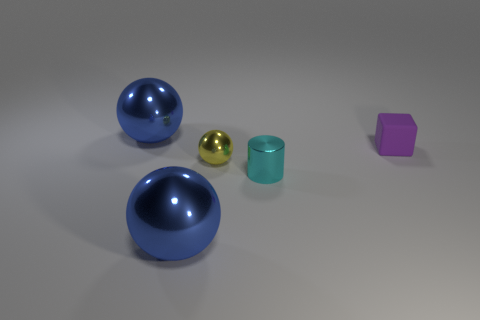What number of other objects are the same size as the rubber object?
Give a very brief answer. 2. What is the size of the sphere that is both in front of the tiny cube and behind the tiny shiny cylinder?
Ensure brevity in your answer.  Small. What number of purple rubber objects have the same shape as the small cyan thing?
Keep it short and to the point. 0. What material is the tiny yellow object?
Make the answer very short. Metal. Is the purple thing the same shape as the cyan object?
Make the answer very short. No. Is there a small thing made of the same material as the small block?
Keep it short and to the point. No. What color is the metal thing that is both in front of the tiny ball and left of the shiny cylinder?
Provide a short and direct response. Blue. What is the material of the big object that is behind the tiny yellow ball?
Your answer should be compact. Metal. Is there another object of the same shape as the yellow thing?
Provide a short and direct response. Yes. How many other objects are there of the same shape as the rubber object?
Keep it short and to the point. 0. 